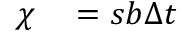<formula> <loc_0><loc_0><loc_500><loc_500>\begin{array} { r l } { \chi } & = b \Delta } \end{array}</formula> 